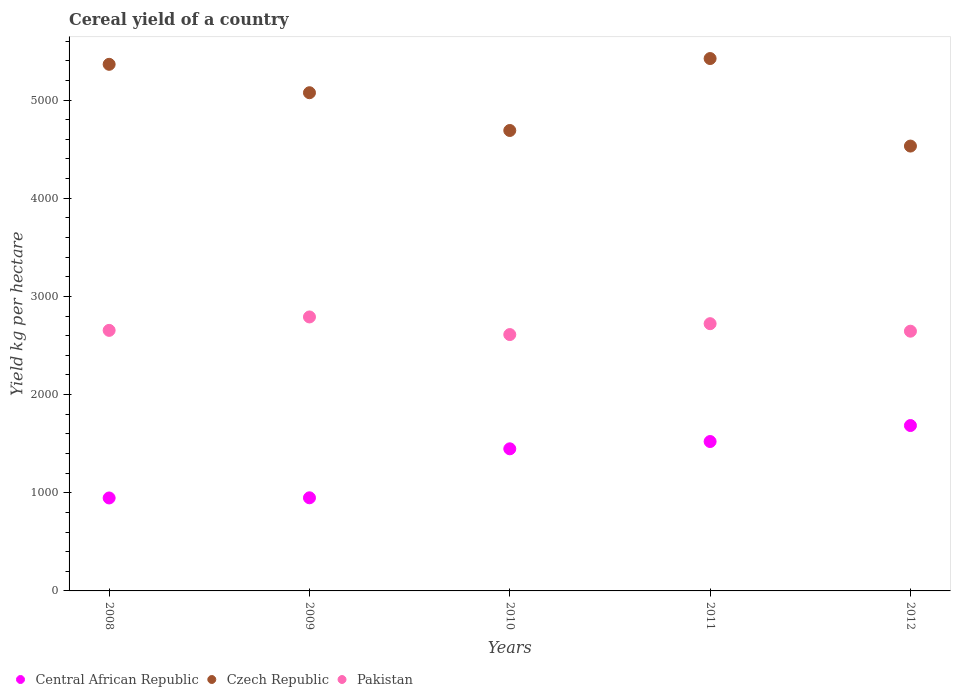What is the total cereal yield in Pakistan in 2009?
Provide a short and direct response. 2790.45. Across all years, what is the maximum total cereal yield in Central African Republic?
Provide a short and direct response. 1684.43. Across all years, what is the minimum total cereal yield in Pakistan?
Offer a very short reply. 2611.05. In which year was the total cereal yield in Czech Republic maximum?
Ensure brevity in your answer.  2011. In which year was the total cereal yield in Pakistan minimum?
Ensure brevity in your answer.  2010. What is the total total cereal yield in Pakistan in the graph?
Ensure brevity in your answer.  1.34e+04. What is the difference between the total cereal yield in Pakistan in 2009 and that in 2011?
Offer a very short reply. 68.49. What is the difference between the total cereal yield in Pakistan in 2012 and the total cereal yield in Central African Republic in 2008?
Ensure brevity in your answer.  1698.65. What is the average total cereal yield in Central African Republic per year?
Offer a very short reply. 1309.72. In the year 2011, what is the difference between the total cereal yield in Pakistan and total cereal yield in Central African Republic?
Offer a very short reply. 1200.34. In how many years, is the total cereal yield in Pakistan greater than 1400 kg per hectare?
Offer a very short reply. 5. What is the ratio of the total cereal yield in Central African Republic in 2009 to that in 2012?
Keep it short and to the point. 0.56. Is the total cereal yield in Pakistan in 2010 less than that in 2011?
Keep it short and to the point. Yes. Is the difference between the total cereal yield in Pakistan in 2011 and 2012 greater than the difference between the total cereal yield in Central African Republic in 2011 and 2012?
Ensure brevity in your answer.  Yes. What is the difference between the highest and the second highest total cereal yield in Czech Republic?
Your answer should be compact. 58.82. What is the difference between the highest and the lowest total cereal yield in Pakistan?
Keep it short and to the point. 179.39. In how many years, is the total cereal yield in Czech Republic greater than the average total cereal yield in Czech Republic taken over all years?
Keep it short and to the point. 3. Is the sum of the total cereal yield in Czech Republic in 2008 and 2009 greater than the maximum total cereal yield in Central African Republic across all years?
Your answer should be compact. Yes. Is the total cereal yield in Czech Republic strictly greater than the total cereal yield in Central African Republic over the years?
Make the answer very short. Yes. Is the total cereal yield in Central African Republic strictly less than the total cereal yield in Czech Republic over the years?
Provide a succinct answer. Yes. How many dotlines are there?
Offer a terse response. 3. Does the graph contain any zero values?
Provide a short and direct response. No. Does the graph contain grids?
Keep it short and to the point. No. How are the legend labels stacked?
Your answer should be compact. Horizontal. What is the title of the graph?
Your answer should be compact. Cereal yield of a country. What is the label or title of the X-axis?
Ensure brevity in your answer.  Years. What is the label or title of the Y-axis?
Your response must be concise. Yield kg per hectare. What is the Yield kg per hectare in Central African Republic in 2008?
Offer a very short reply. 946.77. What is the Yield kg per hectare in Czech Republic in 2008?
Make the answer very short. 5363.53. What is the Yield kg per hectare of Pakistan in 2008?
Ensure brevity in your answer.  2653.72. What is the Yield kg per hectare of Central African Republic in 2009?
Provide a short and direct response. 948.39. What is the Yield kg per hectare in Czech Republic in 2009?
Offer a very short reply. 5074.2. What is the Yield kg per hectare in Pakistan in 2009?
Your answer should be compact. 2790.45. What is the Yield kg per hectare of Central African Republic in 2010?
Ensure brevity in your answer.  1447.4. What is the Yield kg per hectare in Czech Republic in 2010?
Keep it short and to the point. 4689.63. What is the Yield kg per hectare of Pakistan in 2010?
Your response must be concise. 2611.05. What is the Yield kg per hectare of Central African Republic in 2011?
Offer a terse response. 1521.62. What is the Yield kg per hectare in Czech Republic in 2011?
Keep it short and to the point. 5422.35. What is the Yield kg per hectare in Pakistan in 2011?
Give a very brief answer. 2721.96. What is the Yield kg per hectare of Central African Republic in 2012?
Ensure brevity in your answer.  1684.43. What is the Yield kg per hectare of Czech Republic in 2012?
Offer a terse response. 4530.87. What is the Yield kg per hectare of Pakistan in 2012?
Give a very brief answer. 2645.42. Across all years, what is the maximum Yield kg per hectare of Central African Republic?
Provide a short and direct response. 1684.43. Across all years, what is the maximum Yield kg per hectare of Czech Republic?
Make the answer very short. 5422.35. Across all years, what is the maximum Yield kg per hectare of Pakistan?
Offer a terse response. 2790.45. Across all years, what is the minimum Yield kg per hectare of Central African Republic?
Make the answer very short. 946.77. Across all years, what is the minimum Yield kg per hectare in Czech Republic?
Make the answer very short. 4530.87. Across all years, what is the minimum Yield kg per hectare in Pakistan?
Offer a very short reply. 2611.05. What is the total Yield kg per hectare of Central African Republic in the graph?
Keep it short and to the point. 6548.61. What is the total Yield kg per hectare in Czech Republic in the graph?
Your answer should be compact. 2.51e+04. What is the total Yield kg per hectare of Pakistan in the graph?
Provide a succinct answer. 1.34e+04. What is the difference between the Yield kg per hectare of Central African Republic in 2008 and that in 2009?
Keep it short and to the point. -1.63. What is the difference between the Yield kg per hectare of Czech Republic in 2008 and that in 2009?
Make the answer very short. 289.33. What is the difference between the Yield kg per hectare of Pakistan in 2008 and that in 2009?
Provide a short and direct response. -136.72. What is the difference between the Yield kg per hectare of Central African Republic in 2008 and that in 2010?
Ensure brevity in your answer.  -500.63. What is the difference between the Yield kg per hectare of Czech Republic in 2008 and that in 2010?
Ensure brevity in your answer.  673.9. What is the difference between the Yield kg per hectare of Pakistan in 2008 and that in 2010?
Give a very brief answer. 42.67. What is the difference between the Yield kg per hectare of Central African Republic in 2008 and that in 2011?
Provide a succinct answer. -574.86. What is the difference between the Yield kg per hectare of Czech Republic in 2008 and that in 2011?
Offer a terse response. -58.82. What is the difference between the Yield kg per hectare in Pakistan in 2008 and that in 2011?
Your answer should be compact. -68.23. What is the difference between the Yield kg per hectare in Central African Republic in 2008 and that in 2012?
Your response must be concise. -737.66. What is the difference between the Yield kg per hectare of Czech Republic in 2008 and that in 2012?
Ensure brevity in your answer.  832.66. What is the difference between the Yield kg per hectare in Pakistan in 2008 and that in 2012?
Keep it short and to the point. 8.31. What is the difference between the Yield kg per hectare of Central African Republic in 2009 and that in 2010?
Offer a very short reply. -499. What is the difference between the Yield kg per hectare of Czech Republic in 2009 and that in 2010?
Give a very brief answer. 384.57. What is the difference between the Yield kg per hectare in Pakistan in 2009 and that in 2010?
Give a very brief answer. 179.4. What is the difference between the Yield kg per hectare in Central African Republic in 2009 and that in 2011?
Offer a very short reply. -573.23. What is the difference between the Yield kg per hectare in Czech Republic in 2009 and that in 2011?
Give a very brief answer. -348.15. What is the difference between the Yield kg per hectare in Pakistan in 2009 and that in 2011?
Provide a succinct answer. 68.49. What is the difference between the Yield kg per hectare of Central African Republic in 2009 and that in 2012?
Give a very brief answer. -736.04. What is the difference between the Yield kg per hectare of Czech Republic in 2009 and that in 2012?
Your response must be concise. 543.33. What is the difference between the Yield kg per hectare of Pakistan in 2009 and that in 2012?
Make the answer very short. 145.03. What is the difference between the Yield kg per hectare in Central African Republic in 2010 and that in 2011?
Provide a short and direct response. -74.23. What is the difference between the Yield kg per hectare in Czech Republic in 2010 and that in 2011?
Provide a short and direct response. -732.72. What is the difference between the Yield kg per hectare in Pakistan in 2010 and that in 2011?
Offer a very short reply. -110.91. What is the difference between the Yield kg per hectare in Central African Republic in 2010 and that in 2012?
Give a very brief answer. -237.03. What is the difference between the Yield kg per hectare in Czech Republic in 2010 and that in 2012?
Provide a short and direct response. 158.76. What is the difference between the Yield kg per hectare in Pakistan in 2010 and that in 2012?
Offer a terse response. -34.37. What is the difference between the Yield kg per hectare in Central African Republic in 2011 and that in 2012?
Offer a very short reply. -162.81. What is the difference between the Yield kg per hectare in Czech Republic in 2011 and that in 2012?
Provide a short and direct response. 891.48. What is the difference between the Yield kg per hectare in Pakistan in 2011 and that in 2012?
Your response must be concise. 76.54. What is the difference between the Yield kg per hectare in Central African Republic in 2008 and the Yield kg per hectare in Czech Republic in 2009?
Provide a short and direct response. -4127.44. What is the difference between the Yield kg per hectare in Central African Republic in 2008 and the Yield kg per hectare in Pakistan in 2009?
Provide a succinct answer. -1843.68. What is the difference between the Yield kg per hectare in Czech Republic in 2008 and the Yield kg per hectare in Pakistan in 2009?
Keep it short and to the point. 2573.09. What is the difference between the Yield kg per hectare of Central African Republic in 2008 and the Yield kg per hectare of Czech Republic in 2010?
Offer a very short reply. -3742.86. What is the difference between the Yield kg per hectare of Central African Republic in 2008 and the Yield kg per hectare of Pakistan in 2010?
Give a very brief answer. -1664.28. What is the difference between the Yield kg per hectare of Czech Republic in 2008 and the Yield kg per hectare of Pakistan in 2010?
Provide a short and direct response. 2752.48. What is the difference between the Yield kg per hectare in Central African Republic in 2008 and the Yield kg per hectare in Czech Republic in 2011?
Your answer should be very brief. -4475.59. What is the difference between the Yield kg per hectare of Central African Republic in 2008 and the Yield kg per hectare of Pakistan in 2011?
Your answer should be compact. -1775.19. What is the difference between the Yield kg per hectare in Czech Republic in 2008 and the Yield kg per hectare in Pakistan in 2011?
Your answer should be compact. 2641.57. What is the difference between the Yield kg per hectare of Central African Republic in 2008 and the Yield kg per hectare of Czech Republic in 2012?
Keep it short and to the point. -3584.1. What is the difference between the Yield kg per hectare in Central African Republic in 2008 and the Yield kg per hectare in Pakistan in 2012?
Keep it short and to the point. -1698.65. What is the difference between the Yield kg per hectare of Czech Republic in 2008 and the Yield kg per hectare of Pakistan in 2012?
Offer a very short reply. 2718.11. What is the difference between the Yield kg per hectare in Central African Republic in 2009 and the Yield kg per hectare in Czech Republic in 2010?
Give a very brief answer. -3741.24. What is the difference between the Yield kg per hectare in Central African Republic in 2009 and the Yield kg per hectare in Pakistan in 2010?
Your answer should be very brief. -1662.66. What is the difference between the Yield kg per hectare of Czech Republic in 2009 and the Yield kg per hectare of Pakistan in 2010?
Offer a terse response. 2463.15. What is the difference between the Yield kg per hectare of Central African Republic in 2009 and the Yield kg per hectare of Czech Republic in 2011?
Your response must be concise. -4473.96. What is the difference between the Yield kg per hectare of Central African Republic in 2009 and the Yield kg per hectare of Pakistan in 2011?
Ensure brevity in your answer.  -1773.57. What is the difference between the Yield kg per hectare of Czech Republic in 2009 and the Yield kg per hectare of Pakistan in 2011?
Make the answer very short. 2352.24. What is the difference between the Yield kg per hectare in Central African Republic in 2009 and the Yield kg per hectare in Czech Republic in 2012?
Keep it short and to the point. -3582.48. What is the difference between the Yield kg per hectare of Central African Republic in 2009 and the Yield kg per hectare of Pakistan in 2012?
Offer a terse response. -1697.03. What is the difference between the Yield kg per hectare in Czech Republic in 2009 and the Yield kg per hectare in Pakistan in 2012?
Give a very brief answer. 2428.78. What is the difference between the Yield kg per hectare of Central African Republic in 2010 and the Yield kg per hectare of Czech Republic in 2011?
Your answer should be very brief. -3974.95. What is the difference between the Yield kg per hectare of Central African Republic in 2010 and the Yield kg per hectare of Pakistan in 2011?
Your response must be concise. -1274.56. What is the difference between the Yield kg per hectare of Czech Republic in 2010 and the Yield kg per hectare of Pakistan in 2011?
Make the answer very short. 1967.67. What is the difference between the Yield kg per hectare in Central African Republic in 2010 and the Yield kg per hectare in Czech Republic in 2012?
Make the answer very short. -3083.47. What is the difference between the Yield kg per hectare in Central African Republic in 2010 and the Yield kg per hectare in Pakistan in 2012?
Offer a very short reply. -1198.02. What is the difference between the Yield kg per hectare of Czech Republic in 2010 and the Yield kg per hectare of Pakistan in 2012?
Offer a terse response. 2044.21. What is the difference between the Yield kg per hectare of Central African Republic in 2011 and the Yield kg per hectare of Czech Republic in 2012?
Provide a succinct answer. -3009.25. What is the difference between the Yield kg per hectare in Central African Republic in 2011 and the Yield kg per hectare in Pakistan in 2012?
Your answer should be very brief. -1123.8. What is the difference between the Yield kg per hectare of Czech Republic in 2011 and the Yield kg per hectare of Pakistan in 2012?
Provide a succinct answer. 2776.93. What is the average Yield kg per hectare of Central African Republic per year?
Your answer should be very brief. 1309.72. What is the average Yield kg per hectare of Czech Republic per year?
Provide a succinct answer. 5016.12. What is the average Yield kg per hectare of Pakistan per year?
Provide a short and direct response. 2684.52. In the year 2008, what is the difference between the Yield kg per hectare of Central African Republic and Yield kg per hectare of Czech Republic?
Your answer should be compact. -4416.77. In the year 2008, what is the difference between the Yield kg per hectare of Central African Republic and Yield kg per hectare of Pakistan?
Your answer should be very brief. -1706.96. In the year 2008, what is the difference between the Yield kg per hectare of Czech Republic and Yield kg per hectare of Pakistan?
Offer a terse response. 2709.81. In the year 2009, what is the difference between the Yield kg per hectare of Central African Republic and Yield kg per hectare of Czech Republic?
Your answer should be compact. -4125.81. In the year 2009, what is the difference between the Yield kg per hectare in Central African Republic and Yield kg per hectare in Pakistan?
Provide a succinct answer. -1842.05. In the year 2009, what is the difference between the Yield kg per hectare of Czech Republic and Yield kg per hectare of Pakistan?
Provide a short and direct response. 2283.76. In the year 2010, what is the difference between the Yield kg per hectare of Central African Republic and Yield kg per hectare of Czech Republic?
Your response must be concise. -3242.23. In the year 2010, what is the difference between the Yield kg per hectare in Central African Republic and Yield kg per hectare in Pakistan?
Ensure brevity in your answer.  -1163.65. In the year 2010, what is the difference between the Yield kg per hectare in Czech Republic and Yield kg per hectare in Pakistan?
Offer a very short reply. 2078.58. In the year 2011, what is the difference between the Yield kg per hectare in Central African Republic and Yield kg per hectare in Czech Republic?
Give a very brief answer. -3900.73. In the year 2011, what is the difference between the Yield kg per hectare of Central African Republic and Yield kg per hectare of Pakistan?
Your answer should be very brief. -1200.34. In the year 2011, what is the difference between the Yield kg per hectare in Czech Republic and Yield kg per hectare in Pakistan?
Provide a succinct answer. 2700.39. In the year 2012, what is the difference between the Yield kg per hectare in Central African Republic and Yield kg per hectare in Czech Republic?
Ensure brevity in your answer.  -2846.44. In the year 2012, what is the difference between the Yield kg per hectare in Central African Republic and Yield kg per hectare in Pakistan?
Keep it short and to the point. -960.99. In the year 2012, what is the difference between the Yield kg per hectare in Czech Republic and Yield kg per hectare in Pakistan?
Provide a succinct answer. 1885.45. What is the ratio of the Yield kg per hectare in Central African Republic in 2008 to that in 2009?
Give a very brief answer. 1. What is the ratio of the Yield kg per hectare of Czech Republic in 2008 to that in 2009?
Offer a very short reply. 1.06. What is the ratio of the Yield kg per hectare of Pakistan in 2008 to that in 2009?
Provide a short and direct response. 0.95. What is the ratio of the Yield kg per hectare of Central African Republic in 2008 to that in 2010?
Ensure brevity in your answer.  0.65. What is the ratio of the Yield kg per hectare in Czech Republic in 2008 to that in 2010?
Ensure brevity in your answer.  1.14. What is the ratio of the Yield kg per hectare of Pakistan in 2008 to that in 2010?
Make the answer very short. 1.02. What is the ratio of the Yield kg per hectare in Central African Republic in 2008 to that in 2011?
Your answer should be compact. 0.62. What is the ratio of the Yield kg per hectare of Czech Republic in 2008 to that in 2011?
Offer a terse response. 0.99. What is the ratio of the Yield kg per hectare in Pakistan in 2008 to that in 2011?
Offer a very short reply. 0.97. What is the ratio of the Yield kg per hectare in Central African Republic in 2008 to that in 2012?
Your response must be concise. 0.56. What is the ratio of the Yield kg per hectare of Czech Republic in 2008 to that in 2012?
Offer a very short reply. 1.18. What is the ratio of the Yield kg per hectare of Central African Republic in 2009 to that in 2010?
Provide a short and direct response. 0.66. What is the ratio of the Yield kg per hectare in Czech Republic in 2009 to that in 2010?
Keep it short and to the point. 1.08. What is the ratio of the Yield kg per hectare in Pakistan in 2009 to that in 2010?
Provide a succinct answer. 1.07. What is the ratio of the Yield kg per hectare in Central African Republic in 2009 to that in 2011?
Ensure brevity in your answer.  0.62. What is the ratio of the Yield kg per hectare in Czech Republic in 2009 to that in 2011?
Give a very brief answer. 0.94. What is the ratio of the Yield kg per hectare in Pakistan in 2009 to that in 2011?
Offer a very short reply. 1.03. What is the ratio of the Yield kg per hectare of Central African Republic in 2009 to that in 2012?
Make the answer very short. 0.56. What is the ratio of the Yield kg per hectare in Czech Republic in 2009 to that in 2012?
Ensure brevity in your answer.  1.12. What is the ratio of the Yield kg per hectare of Pakistan in 2009 to that in 2012?
Provide a short and direct response. 1.05. What is the ratio of the Yield kg per hectare of Central African Republic in 2010 to that in 2011?
Make the answer very short. 0.95. What is the ratio of the Yield kg per hectare in Czech Republic in 2010 to that in 2011?
Ensure brevity in your answer.  0.86. What is the ratio of the Yield kg per hectare of Pakistan in 2010 to that in 2011?
Make the answer very short. 0.96. What is the ratio of the Yield kg per hectare of Central African Republic in 2010 to that in 2012?
Your response must be concise. 0.86. What is the ratio of the Yield kg per hectare of Czech Republic in 2010 to that in 2012?
Your answer should be compact. 1.03. What is the ratio of the Yield kg per hectare in Pakistan in 2010 to that in 2012?
Your response must be concise. 0.99. What is the ratio of the Yield kg per hectare of Central African Republic in 2011 to that in 2012?
Your response must be concise. 0.9. What is the ratio of the Yield kg per hectare in Czech Republic in 2011 to that in 2012?
Your answer should be very brief. 1.2. What is the ratio of the Yield kg per hectare in Pakistan in 2011 to that in 2012?
Your answer should be very brief. 1.03. What is the difference between the highest and the second highest Yield kg per hectare of Central African Republic?
Give a very brief answer. 162.81. What is the difference between the highest and the second highest Yield kg per hectare in Czech Republic?
Offer a very short reply. 58.82. What is the difference between the highest and the second highest Yield kg per hectare in Pakistan?
Offer a very short reply. 68.49. What is the difference between the highest and the lowest Yield kg per hectare of Central African Republic?
Make the answer very short. 737.66. What is the difference between the highest and the lowest Yield kg per hectare of Czech Republic?
Ensure brevity in your answer.  891.48. What is the difference between the highest and the lowest Yield kg per hectare of Pakistan?
Make the answer very short. 179.4. 